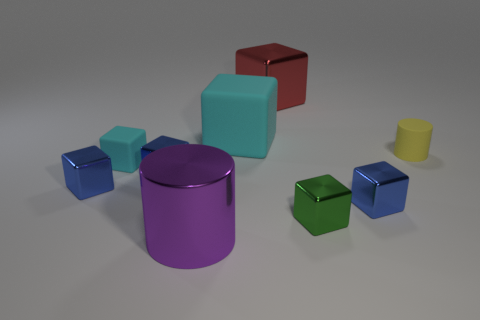Subtract all blue blocks. How many were subtracted if there are1blue blocks left? 2 Subtract all purple cylinders. How many blue cubes are left? 3 Subtract 3 blocks. How many blocks are left? 4 Subtract all red cubes. How many cubes are left? 6 Subtract all red shiny cubes. How many cubes are left? 6 Subtract all gray blocks. Subtract all red cylinders. How many blocks are left? 7 Add 1 yellow matte cylinders. How many objects exist? 10 Subtract all blocks. How many objects are left? 2 Subtract 0 gray blocks. How many objects are left? 9 Subtract all tiny green metal balls. Subtract all big matte objects. How many objects are left? 8 